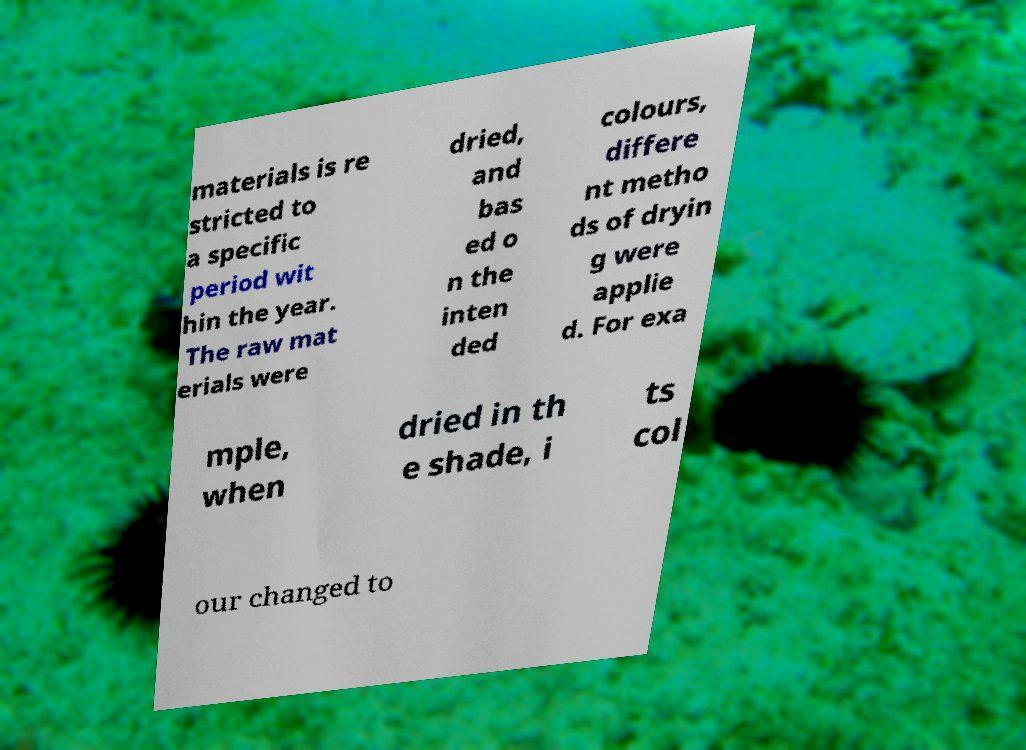What messages or text are displayed in this image? I need them in a readable, typed format. materials is re stricted to a specific period wit hin the year. The raw mat erials were dried, and bas ed o n the inten ded colours, differe nt metho ds of dryin g were applie d. For exa mple, when dried in th e shade, i ts col our changed to 